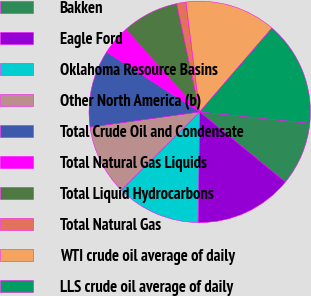<chart> <loc_0><loc_0><loc_500><loc_500><pie_chart><fcel>Bakken<fcel>Eagle Ford<fcel>Oklahoma Resource Basins<fcel>Other North America (b)<fcel>Total Crude Oil and Condensate<fcel>Total Natural Gas Liquids<fcel>Total Liquid Hydrocarbons<fcel>Total Natural Gas<fcel>WTI crude oil average of daily<fcel>LLS crude oil average of daily<nl><fcel>9.28%<fcel>14.31%<fcel>12.3%<fcel>10.28%<fcel>11.29%<fcel>4.29%<fcel>8.27%<fcel>1.36%<fcel>13.3%<fcel>15.32%<nl></chart> 